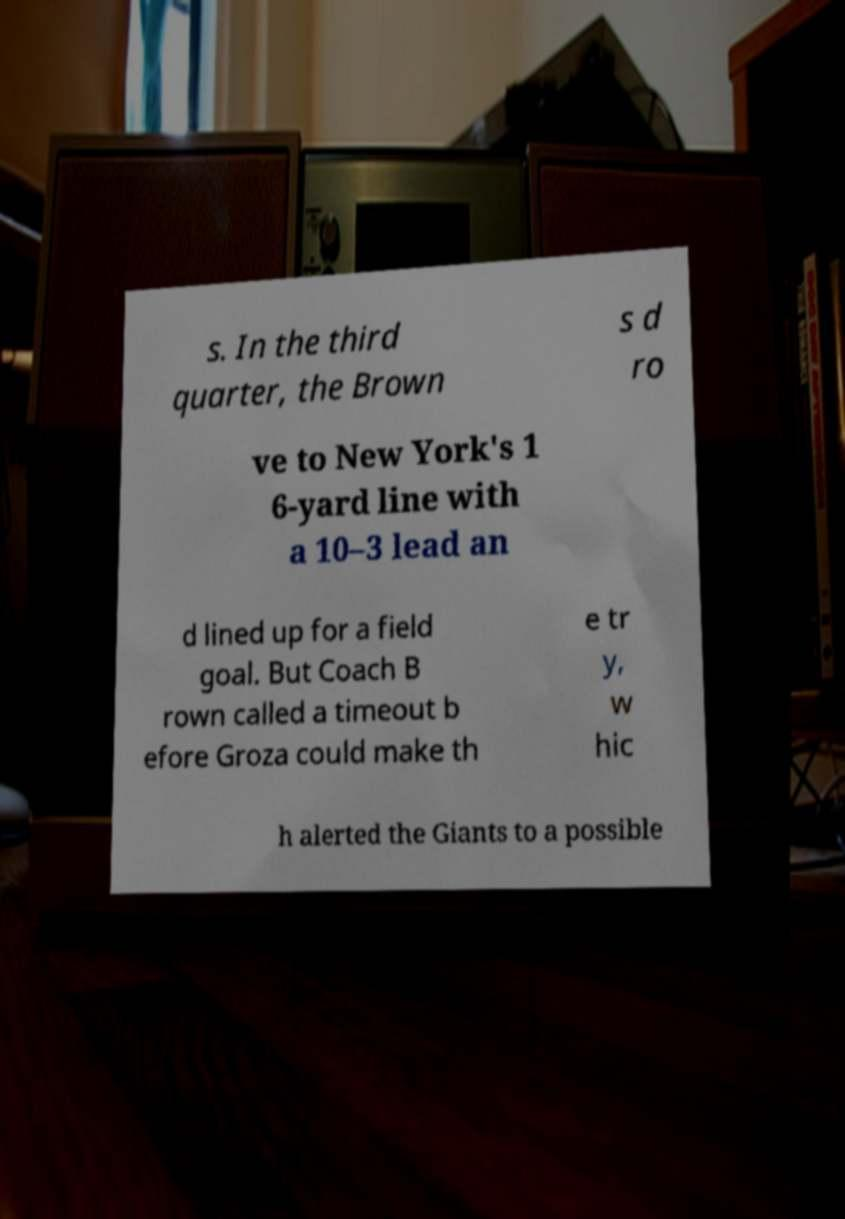Please read and relay the text visible in this image. What does it say? s. In the third quarter, the Brown s d ro ve to New York's 1 6-yard line with a 10–3 lead an d lined up for a field goal. But Coach B rown called a timeout b efore Groza could make th e tr y, w hic h alerted the Giants to a possible 